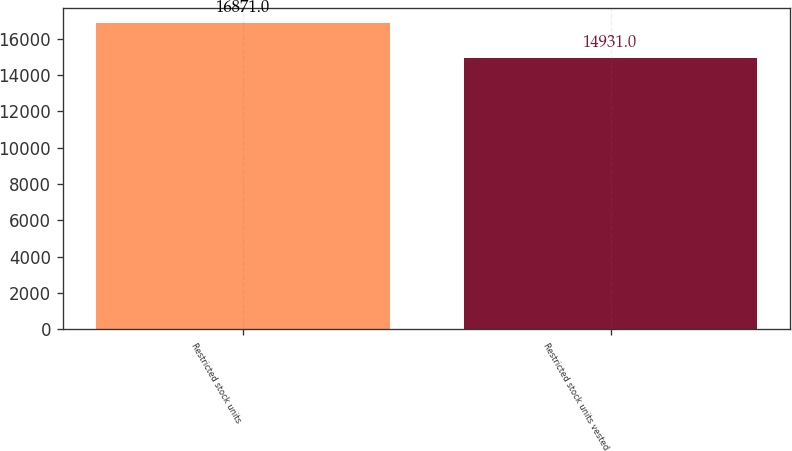Convert chart. <chart><loc_0><loc_0><loc_500><loc_500><bar_chart><fcel>Restricted stock units<fcel>Restricted stock units vested<nl><fcel>16871<fcel>14931<nl></chart> 